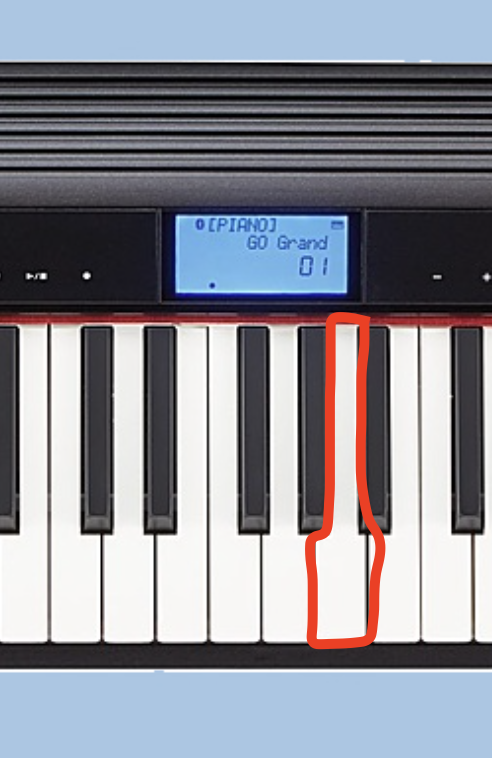Which piano key is the red circle highlighting? The red circle in the image appears to be highlighting the E key on the piano keyboard. 